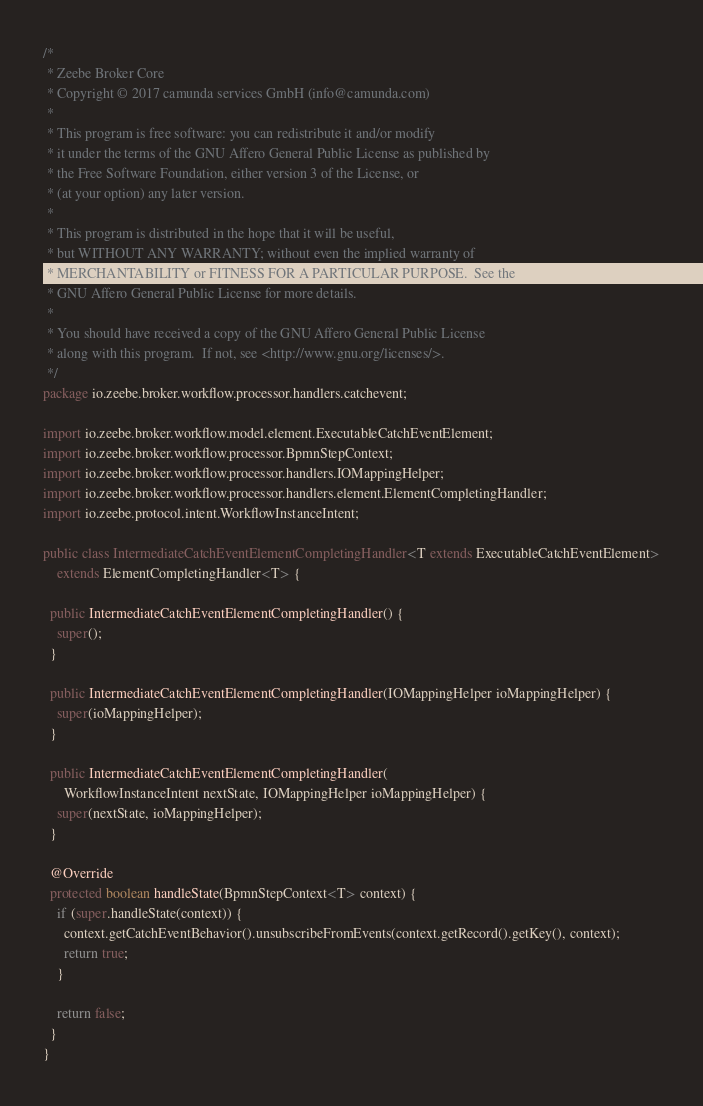<code> <loc_0><loc_0><loc_500><loc_500><_Java_>/*
 * Zeebe Broker Core
 * Copyright © 2017 camunda services GmbH (info@camunda.com)
 *
 * This program is free software: you can redistribute it and/or modify
 * it under the terms of the GNU Affero General Public License as published by
 * the Free Software Foundation, either version 3 of the License, or
 * (at your option) any later version.
 *
 * This program is distributed in the hope that it will be useful,
 * but WITHOUT ANY WARRANTY; without even the implied warranty of
 * MERCHANTABILITY or FITNESS FOR A PARTICULAR PURPOSE.  See the
 * GNU Affero General Public License for more details.
 *
 * You should have received a copy of the GNU Affero General Public License
 * along with this program.  If not, see <http://www.gnu.org/licenses/>.
 */
package io.zeebe.broker.workflow.processor.handlers.catchevent;

import io.zeebe.broker.workflow.model.element.ExecutableCatchEventElement;
import io.zeebe.broker.workflow.processor.BpmnStepContext;
import io.zeebe.broker.workflow.processor.handlers.IOMappingHelper;
import io.zeebe.broker.workflow.processor.handlers.element.ElementCompletingHandler;
import io.zeebe.protocol.intent.WorkflowInstanceIntent;

public class IntermediateCatchEventElementCompletingHandler<T extends ExecutableCatchEventElement>
    extends ElementCompletingHandler<T> {

  public IntermediateCatchEventElementCompletingHandler() {
    super();
  }

  public IntermediateCatchEventElementCompletingHandler(IOMappingHelper ioMappingHelper) {
    super(ioMappingHelper);
  }

  public IntermediateCatchEventElementCompletingHandler(
      WorkflowInstanceIntent nextState, IOMappingHelper ioMappingHelper) {
    super(nextState, ioMappingHelper);
  }

  @Override
  protected boolean handleState(BpmnStepContext<T> context) {
    if (super.handleState(context)) {
      context.getCatchEventBehavior().unsubscribeFromEvents(context.getRecord().getKey(), context);
      return true;
    }

    return false;
  }
}
</code> 